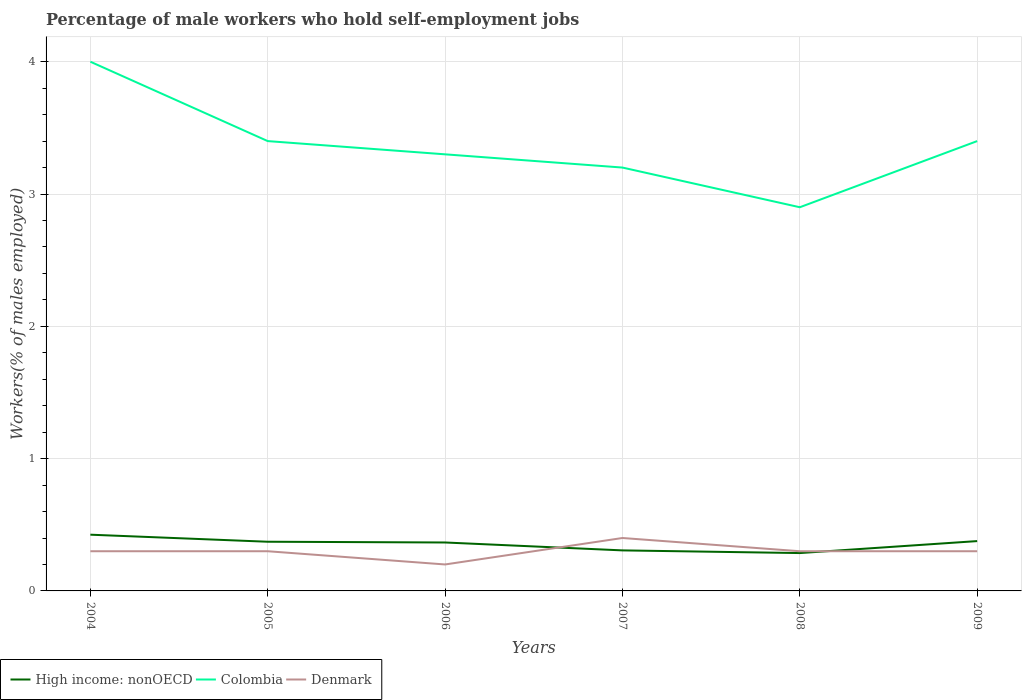Is the number of lines equal to the number of legend labels?
Your response must be concise. Yes. Across all years, what is the maximum percentage of self-employed male workers in High income: nonOECD?
Provide a short and direct response. 0.29. In which year was the percentage of self-employed male workers in Denmark maximum?
Provide a succinct answer. 2006. What is the total percentage of self-employed male workers in Denmark in the graph?
Offer a very short reply. 0. What is the difference between the highest and the second highest percentage of self-employed male workers in Denmark?
Provide a succinct answer. 0.2. How many lines are there?
Your response must be concise. 3. How many years are there in the graph?
Ensure brevity in your answer.  6. What is the difference between two consecutive major ticks on the Y-axis?
Your answer should be compact. 1. Does the graph contain grids?
Give a very brief answer. Yes. Where does the legend appear in the graph?
Keep it short and to the point. Bottom left. What is the title of the graph?
Provide a short and direct response. Percentage of male workers who hold self-employment jobs. Does "Sri Lanka" appear as one of the legend labels in the graph?
Your answer should be compact. No. What is the label or title of the X-axis?
Offer a very short reply. Years. What is the label or title of the Y-axis?
Offer a very short reply. Workers(% of males employed). What is the Workers(% of males employed) of High income: nonOECD in 2004?
Provide a short and direct response. 0.42. What is the Workers(% of males employed) in Colombia in 2004?
Ensure brevity in your answer.  4. What is the Workers(% of males employed) in Denmark in 2004?
Provide a short and direct response. 0.3. What is the Workers(% of males employed) of High income: nonOECD in 2005?
Keep it short and to the point. 0.37. What is the Workers(% of males employed) in Colombia in 2005?
Keep it short and to the point. 3.4. What is the Workers(% of males employed) in Denmark in 2005?
Give a very brief answer. 0.3. What is the Workers(% of males employed) of High income: nonOECD in 2006?
Your answer should be compact. 0.37. What is the Workers(% of males employed) of Colombia in 2006?
Provide a short and direct response. 3.3. What is the Workers(% of males employed) in Denmark in 2006?
Offer a very short reply. 0.2. What is the Workers(% of males employed) of High income: nonOECD in 2007?
Provide a short and direct response. 0.31. What is the Workers(% of males employed) in Colombia in 2007?
Offer a terse response. 3.2. What is the Workers(% of males employed) of Denmark in 2007?
Give a very brief answer. 0.4. What is the Workers(% of males employed) of High income: nonOECD in 2008?
Offer a very short reply. 0.29. What is the Workers(% of males employed) in Colombia in 2008?
Your answer should be compact. 2.9. What is the Workers(% of males employed) in Denmark in 2008?
Provide a succinct answer. 0.3. What is the Workers(% of males employed) in High income: nonOECD in 2009?
Offer a terse response. 0.38. What is the Workers(% of males employed) in Colombia in 2009?
Provide a short and direct response. 3.4. What is the Workers(% of males employed) of Denmark in 2009?
Your answer should be compact. 0.3. Across all years, what is the maximum Workers(% of males employed) in High income: nonOECD?
Ensure brevity in your answer.  0.42. Across all years, what is the maximum Workers(% of males employed) in Denmark?
Your answer should be very brief. 0.4. Across all years, what is the minimum Workers(% of males employed) in High income: nonOECD?
Make the answer very short. 0.29. Across all years, what is the minimum Workers(% of males employed) of Colombia?
Ensure brevity in your answer.  2.9. Across all years, what is the minimum Workers(% of males employed) in Denmark?
Give a very brief answer. 0.2. What is the total Workers(% of males employed) of High income: nonOECD in the graph?
Offer a very short reply. 2.13. What is the total Workers(% of males employed) in Colombia in the graph?
Offer a very short reply. 20.2. What is the total Workers(% of males employed) in Denmark in the graph?
Keep it short and to the point. 1.8. What is the difference between the Workers(% of males employed) of High income: nonOECD in 2004 and that in 2005?
Provide a succinct answer. 0.05. What is the difference between the Workers(% of males employed) in Denmark in 2004 and that in 2005?
Give a very brief answer. 0. What is the difference between the Workers(% of males employed) of High income: nonOECD in 2004 and that in 2006?
Ensure brevity in your answer.  0.06. What is the difference between the Workers(% of males employed) of Colombia in 2004 and that in 2006?
Offer a very short reply. 0.7. What is the difference between the Workers(% of males employed) of High income: nonOECD in 2004 and that in 2007?
Offer a terse response. 0.12. What is the difference between the Workers(% of males employed) in Colombia in 2004 and that in 2007?
Give a very brief answer. 0.8. What is the difference between the Workers(% of males employed) of High income: nonOECD in 2004 and that in 2008?
Offer a terse response. 0.14. What is the difference between the Workers(% of males employed) in Colombia in 2004 and that in 2008?
Keep it short and to the point. 1.1. What is the difference between the Workers(% of males employed) of High income: nonOECD in 2004 and that in 2009?
Give a very brief answer. 0.05. What is the difference between the Workers(% of males employed) in Colombia in 2004 and that in 2009?
Make the answer very short. 0.6. What is the difference between the Workers(% of males employed) in Denmark in 2004 and that in 2009?
Offer a very short reply. 0. What is the difference between the Workers(% of males employed) of High income: nonOECD in 2005 and that in 2006?
Offer a very short reply. 0.01. What is the difference between the Workers(% of males employed) of Colombia in 2005 and that in 2006?
Your answer should be very brief. 0.1. What is the difference between the Workers(% of males employed) of Denmark in 2005 and that in 2006?
Provide a succinct answer. 0.1. What is the difference between the Workers(% of males employed) in High income: nonOECD in 2005 and that in 2007?
Keep it short and to the point. 0.07. What is the difference between the Workers(% of males employed) in Colombia in 2005 and that in 2007?
Provide a short and direct response. 0.2. What is the difference between the Workers(% of males employed) of High income: nonOECD in 2005 and that in 2008?
Provide a short and direct response. 0.09. What is the difference between the Workers(% of males employed) in Colombia in 2005 and that in 2008?
Provide a succinct answer. 0.5. What is the difference between the Workers(% of males employed) of High income: nonOECD in 2005 and that in 2009?
Your response must be concise. -0. What is the difference between the Workers(% of males employed) in High income: nonOECD in 2006 and that in 2007?
Your answer should be compact. 0.06. What is the difference between the Workers(% of males employed) in Colombia in 2006 and that in 2007?
Keep it short and to the point. 0.1. What is the difference between the Workers(% of males employed) in Denmark in 2006 and that in 2007?
Provide a succinct answer. -0.2. What is the difference between the Workers(% of males employed) in High income: nonOECD in 2006 and that in 2008?
Provide a short and direct response. 0.08. What is the difference between the Workers(% of males employed) in Colombia in 2006 and that in 2008?
Offer a terse response. 0.4. What is the difference between the Workers(% of males employed) in High income: nonOECD in 2006 and that in 2009?
Provide a short and direct response. -0.01. What is the difference between the Workers(% of males employed) in Denmark in 2006 and that in 2009?
Give a very brief answer. -0.1. What is the difference between the Workers(% of males employed) in High income: nonOECD in 2007 and that in 2008?
Offer a terse response. 0.02. What is the difference between the Workers(% of males employed) in High income: nonOECD in 2007 and that in 2009?
Provide a short and direct response. -0.07. What is the difference between the Workers(% of males employed) in High income: nonOECD in 2008 and that in 2009?
Keep it short and to the point. -0.09. What is the difference between the Workers(% of males employed) in Colombia in 2008 and that in 2009?
Your response must be concise. -0.5. What is the difference between the Workers(% of males employed) of Denmark in 2008 and that in 2009?
Your answer should be compact. 0. What is the difference between the Workers(% of males employed) of High income: nonOECD in 2004 and the Workers(% of males employed) of Colombia in 2005?
Keep it short and to the point. -2.98. What is the difference between the Workers(% of males employed) in High income: nonOECD in 2004 and the Workers(% of males employed) in Denmark in 2005?
Provide a short and direct response. 0.12. What is the difference between the Workers(% of males employed) in Colombia in 2004 and the Workers(% of males employed) in Denmark in 2005?
Offer a terse response. 3.7. What is the difference between the Workers(% of males employed) of High income: nonOECD in 2004 and the Workers(% of males employed) of Colombia in 2006?
Your answer should be very brief. -2.88. What is the difference between the Workers(% of males employed) in High income: nonOECD in 2004 and the Workers(% of males employed) in Denmark in 2006?
Your response must be concise. 0.23. What is the difference between the Workers(% of males employed) in High income: nonOECD in 2004 and the Workers(% of males employed) in Colombia in 2007?
Offer a terse response. -2.77. What is the difference between the Workers(% of males employed) in High income: nonOECD in 2004 and the Workers(% of males employed) in Denmark in 2007?
Make the answer very short. 0.03. What is the difference between the Workers(% of males employed) in High income: nonOECD in 2004 and the Workers(% of males employed) in Colombia in 2008?
Offer a terse response. -2.48. What is the difference between the Workers(% of males employed) of High income: nonOECD in 2004 and the Workers(% of males employed) of Denmark in 2008?
Keep it short and to the point. 0.12. What is the difference between the Workers(% of males employed) in High income: nonOECD in 2004 and the Workers(% of males employed) in Colombia in 2009?
Keep it short and to the point. -2.98. What is the difference between the Workers(% of males employed) in High income: nonOECD in 2005 and the Workers(% of males employed) in Colombia in 2006?
Your answer should be compact. -2.93. What is the difference between the Workers(% of males employed) of High income: nonOECD in 2005 and the Workers(% of males employed) of Denmark in 2006?
Provide a succinct answer. 0.17. What is the difference between the Workers(% of males employed) of High income: nonOECD in 2005 and the Workers(% of males employed) of Colombia in 2007?
Give a very brief answer. -2.83. What is the difference between the Workers(% of males employed) in High income: nonOECD in 2005 and the Workers(% of males employed) in Denmark in 2007?
Keep it short and to the point. -0.03. What is the difference between the Workers(% of males employed) of High income: nonOECD in 2005 and the Workers(% of males employed) of Colombia in 2008?
Ensure brevity in your answer.  -2.53. What is the difference between the Workers(% of males employed) in High income: nonOECD in 2005 and the Workers(% of males employed) in Denmark in 2008?
Provide a succinct answer. 0.07. What is the difference between the Workers(% of males employed) in High income: nonOECD in 2005 and the Workers(% of males employed) in Colombia in 2009?
Offer a very short reply. -3.03. What is the difference between the Workers(% of males employed) of High income: nonOECD in 2005 and the Workers(% of males employed) of Denmark in 2009?
Give a very brief answer. 0.07. What is the difference between the Workers(% of males employed) in High income: nonOECD in 2006 and the Workers(% of males employed) in Colombia in 2007?
Ensure brevity in your answer.  -2.83. What is the difference between the Workers(% of males employed) of High income: nonOECD in 2006 and the Workers(% of males employed) of Denmark in 2007?
Your answer should be very brief. -0.03. What is the difference between the Workers(% of males employed) of High income: nonOECD in 2006 and the Workers(% of males employed) of Colombia in 2008?
Your answer should be compact. -2.53. What is the difference between the Workers(% of males employed) of High income: nonOECD in 2006 and the Workers(% of males employed) of Denmark in 2008?
Offer a very short reply. 0.07. What is the difference between the Workers(% of males employed) of Colombia in 2006 and the Workers(% of males employed) of Denmark in 2008?
Your answer should be very brief. 3. What is the difference between the Workers(% of males employed) in High income: nonOECD in 2006 and the Workers(% of males employed) in Colombia in 2009?
Ensure brevity in your answer.  -3.03. What is the difference between the Workers(% of males employed) in High income: nonOECD in 2006 and the Workers(% of males employed) in Denmark in 2009?
Ensure brevity in your answer.  0.07. What is the difference between the Workers(% of males employed) of High income: nonOECD in 2007 and the Workers(% of males employed) of Colombia in 2008?
Your response must be concise. -2.59. What is the difference between the Workers(% of males employed) of High income: nonOECD in 2007 and the Workers(% of males employed) of Denmark in 2008?
Offer a terse response. 0.01. What is the difference between the Workers(% of males employed) in Colombia in 2007 and the Workers(% of males employed) in Denmark in 2008?
Make the answer very short. 2.9. What is the difference between the Workers(% of males employed) in High income: nonOECD in 2007 and the Workers(% of males employed) in Colombia in 2009?
Provide a short and direct response. -3.09. What is the difference between the Workers(% of males employed) in High income: nonOECD in 2007 and the Workers(% of males employed) in Denmark in 2009?
Your answer should be very brief. 0.01. What is the difference between the Workers(% of males employed) of High income: nonOECD in 2008 and the Workers(% of males employed) of Colombia in 2009?
Keep it short and to the point. -3.11. What is the difference between the Workers(% of males employed) of High income: nonOECD in 2008 and the Workers(% of males employed) of Denmark in 2009?
Your answer should be compact. -0.01. What is the average Workers(% of males employed) in High income: nonOECD per year?
Provide a succinct answer. 0.36. What is the average Workers(% of males employed) of Colombia per year?
Your answer should be compact. 3.37. In the year 2004, what is the difference between the Workers(% of males employed) in High income: nonOECD and Workers(% of males employed) in Colombia?
Give a very brief answer. -3.58. In the year 2004, what is the difference between the Workers(% of males employed) in High income: nonOECD and Workers(% of males employed) in Denmark?
Your answer should be compact. 0.12. In the year 2005, what is the difference between the Workers(% of males employed) of High income: nonOECD and Workers(% of males employed) of Colombia?
Your answer should be very brief. -3.03. In the year 2005, what is the difference between the Workers(% of males employed) of High income: nonOECD and Workers(% of males employed) of Denmark?
Keep it short and to the point. 0.07. In the year 2005, what is the difference between the Workers(% of males employed) in Colombia and Workers(% of males employed) in Denmark?
Your answer should be compact. 3.1. In the year 2006, what is the difference between the Workers(% of males employed) of High income: nonOECD and Workers(% of males employed) of Colombia?
Provide a succinct answer. -2.93. In the year 2006, what is the difference between the Workers(% of males employed) of High income: nonOECD and Workers(% of males employed) of Denmark?
Your answer should be compact. 0.17. In the year 2007, what is the difference between the Workers(% of males employed) in High income: nonOECD and Workers(% of males employed) in Colombia?
Your answer should be very brief. -2.89. In the year 2007, what is the difference between the Workers(% of males employed) of High income: nonOECD and Workers(% of males employed) of Denmark?
Your answer should be very brief. -0.09. In the year 2008, what is the difference between the Workers(% of males employed) of High income: nonOECD and Workers(% of males employed) of Colombia?
Offer a very short reply. -2.61. In the year 2008, what is the difference between the Workers(% of males employed) in High income: nonOECD and Workers(% of males employed) in Denmark?
Your response must be concise. -0.01. In the year 2008, what is the difference between the Workers(% of males employed) of Colombia and Workers(% of males employed) of Denmark?
Give a very brief answer. 2.6. In the year 2009, what is the difference between the Workers(% of males employed) in High income: nonOECD and Workers(% of males employed) in Colombia?
Offer a terse response. -3.02. In the year 2009, what is the difference between the Workers(% of males employed) in High income: nonOECD and Workers(% of males employed) in Denmark?
Ensure brevity in your answer.  0.08. What is the ratio of the Workers(% of males employed) of High income: nonOECD in 2004 to that in 2005?
Give a very brief answer. 1.14. What is the ratio of the Workers(% of males employed) of Colombia in 2004 to that in 2005?
Your answer should be very brief. 1.18. What is the ratio of the Workers(% of males employed) in High income: nonOECD in 2004 to that in 2006?
Your response must be concise. 1.16. What is the ratio of the Workers(% of males employed) of Colombia in 2004 to that in 2006?
Ensure brevity in your answer.  1.21. What is the ratio of the Workers(% of males employed) in Denmark in 2004 to that in 2006?
Your response must be concise. 1.5. What is the ratio of the Workers(% of males employed) in High income: nonOECD in 2004 to that in 2007?
Keep it short and to the point. 1.39. What is the ratio of the Workers(% of males employed) of Denmark in 2004 to that in 2007?
Provide a short and direct response. 0.75. What is the ratio of the Workers(% of males employed) of High income: nonOECD in 2004 to that in 2008?
Your answer should be very brief. 1.49. What is the ratio of the Workers(% of males employed) in Colombia in 2004 to that in 2008?
Your response must be concise. 1.38. What is the ratio of the Workers(% of males employed) of Denmark in 2004 to that in 2008?
Provide a succinct answer. 1. What is the ratio of the Workers(% of males employed) in High income: nonOECD in 2004 to that in 2009?
Make the answer very short. 1.13. What is the ratio of the Workers(% of males employed) of Colombia in 2004 to that in 2009?
Offer a terse response. 1.18. What is the ratio of the Workers(% of males employed) in Denmark in 2004 to that in 2009?
Ensure brevity in your answer.  1. What is the ratio of the Workers(% of males employed) of High income: nonOECD in 2005 to that in 2006?
Make the answer very short. 1.02. What is the ratio of the Workers(% of males employed) of Colombia in 2005 to that in 2006?
Give a very brief answer. 1.03. What is the ratio of the Workers(% of males employed) of Denmark in 2005 to that in 2006?
Offer a very short reply. 1.5. What is the ratio of the Workers(% of males employed) of High income: nonOECD in 2005 to that in 2007?
Your answer should be compact. 1.21. What is the ratio of the Workers(% of males employed) of Colombia in 2005 to that in 2007?
Your answer should be very brief. 1.06. What is the ratio of the Workers(% of males employed) in High income: nonOECD in 2005 to that in 2008?
Give a very brief answer. 1.3. What is the ratio of the Workers(% of males employed) of Colombia in 2005 to that in 2008?
Offer a very short reply. 1.17. What is the ratio of the Workers(% of males employed) in High income: nonOECD in 2005 to that in 2009?
Your answer should be compact. 0.99. What is the ratio of the Workers(% of males employed) of Colombia in 2005 to that in 2009?
Offer a terse response. 1. What is the ratio of the Workers(% of males employed) in Denmark in 2005 to that in 2009?
Keep it short and to the point. 1. What is the ratio of the Workers(% of males employed) of High income: nonOECD in 2006 to that in 2007?
Ensure brevity in your answer.  1.2. What is the ratio of the Workers(% of males employed) in Colombia in 2006 to that in 2007?
Ensure brevity in your answer.  1.03. What is the ratio of the Workers(% of males employed) in High income: nonOECD in 2006 to that in 2008?
Your answer should be very brief. 1.28. What is the ratio of the Workers(% of males employed) of Colombia in 2006 to that in 2008?
Make the answer very short. 1.14. What is the ratio of the Workers(% of males employed) of Denmark in 2006 to that in 2008?
Offer a very short reply. 0.67. What is the ratio of the Workers(% of males employed) of Colombia in 2006 to that in 2009?
Provide a succinct answer. 0.97. What is the ratio of the Workers(% of males employed) of Denmark in 2006 to that in 2009?
Provide a short and direct response. 0.67. What is the ratio of the Workers(% of males employed) in High income: nonOECD in 2007 to that in 2008?
Offer a terse response. 1.07. What is the ratio of the Workers(% of males employed) of Colombia in 2007 to that in 2008?
Keep it short and to the point. 1.1. What is the ratio of the Workers(% of males employed) of Denmark in 2007 to that in 2008?
Your answer should be compact. 1.33. What is the ratio of the Workers(% of males employed) of High income: nonOECD in 2007 to that in 2009?
Offer a terse response. 0.81. What is the ratio of the Workers(% of males employed) in Colombia in 2007 to that in 2009?
Your answer should be compact. 0.94. What is the ratio of the Workers(% of males employed) of High income: nonOECD in 2008 to that in 2009?
Make the answer very short. 0.76. What is the ratio of the Workers(% of males employed) in Colombia in 2008 to that in 2009?
Your answer should be compact. 0.85. What is the difference between the highest and the second highest Workers(% of males employed) of High income: nonOECD?
Your answer should be very brief. 0.05. What is the difference between the highest and the second highest Workers(% of males employed) in Colombia?
Your response must be concise. 0.6. What is the difference between the highest and the lowest Workers(% of males employed) of High income: nonOECD?
Provide a short and direct response. 0.14. What is the difference between the highest and the lowest Workers(% of males employed) of Denmark?
Give a very brief answer. 0.2. 